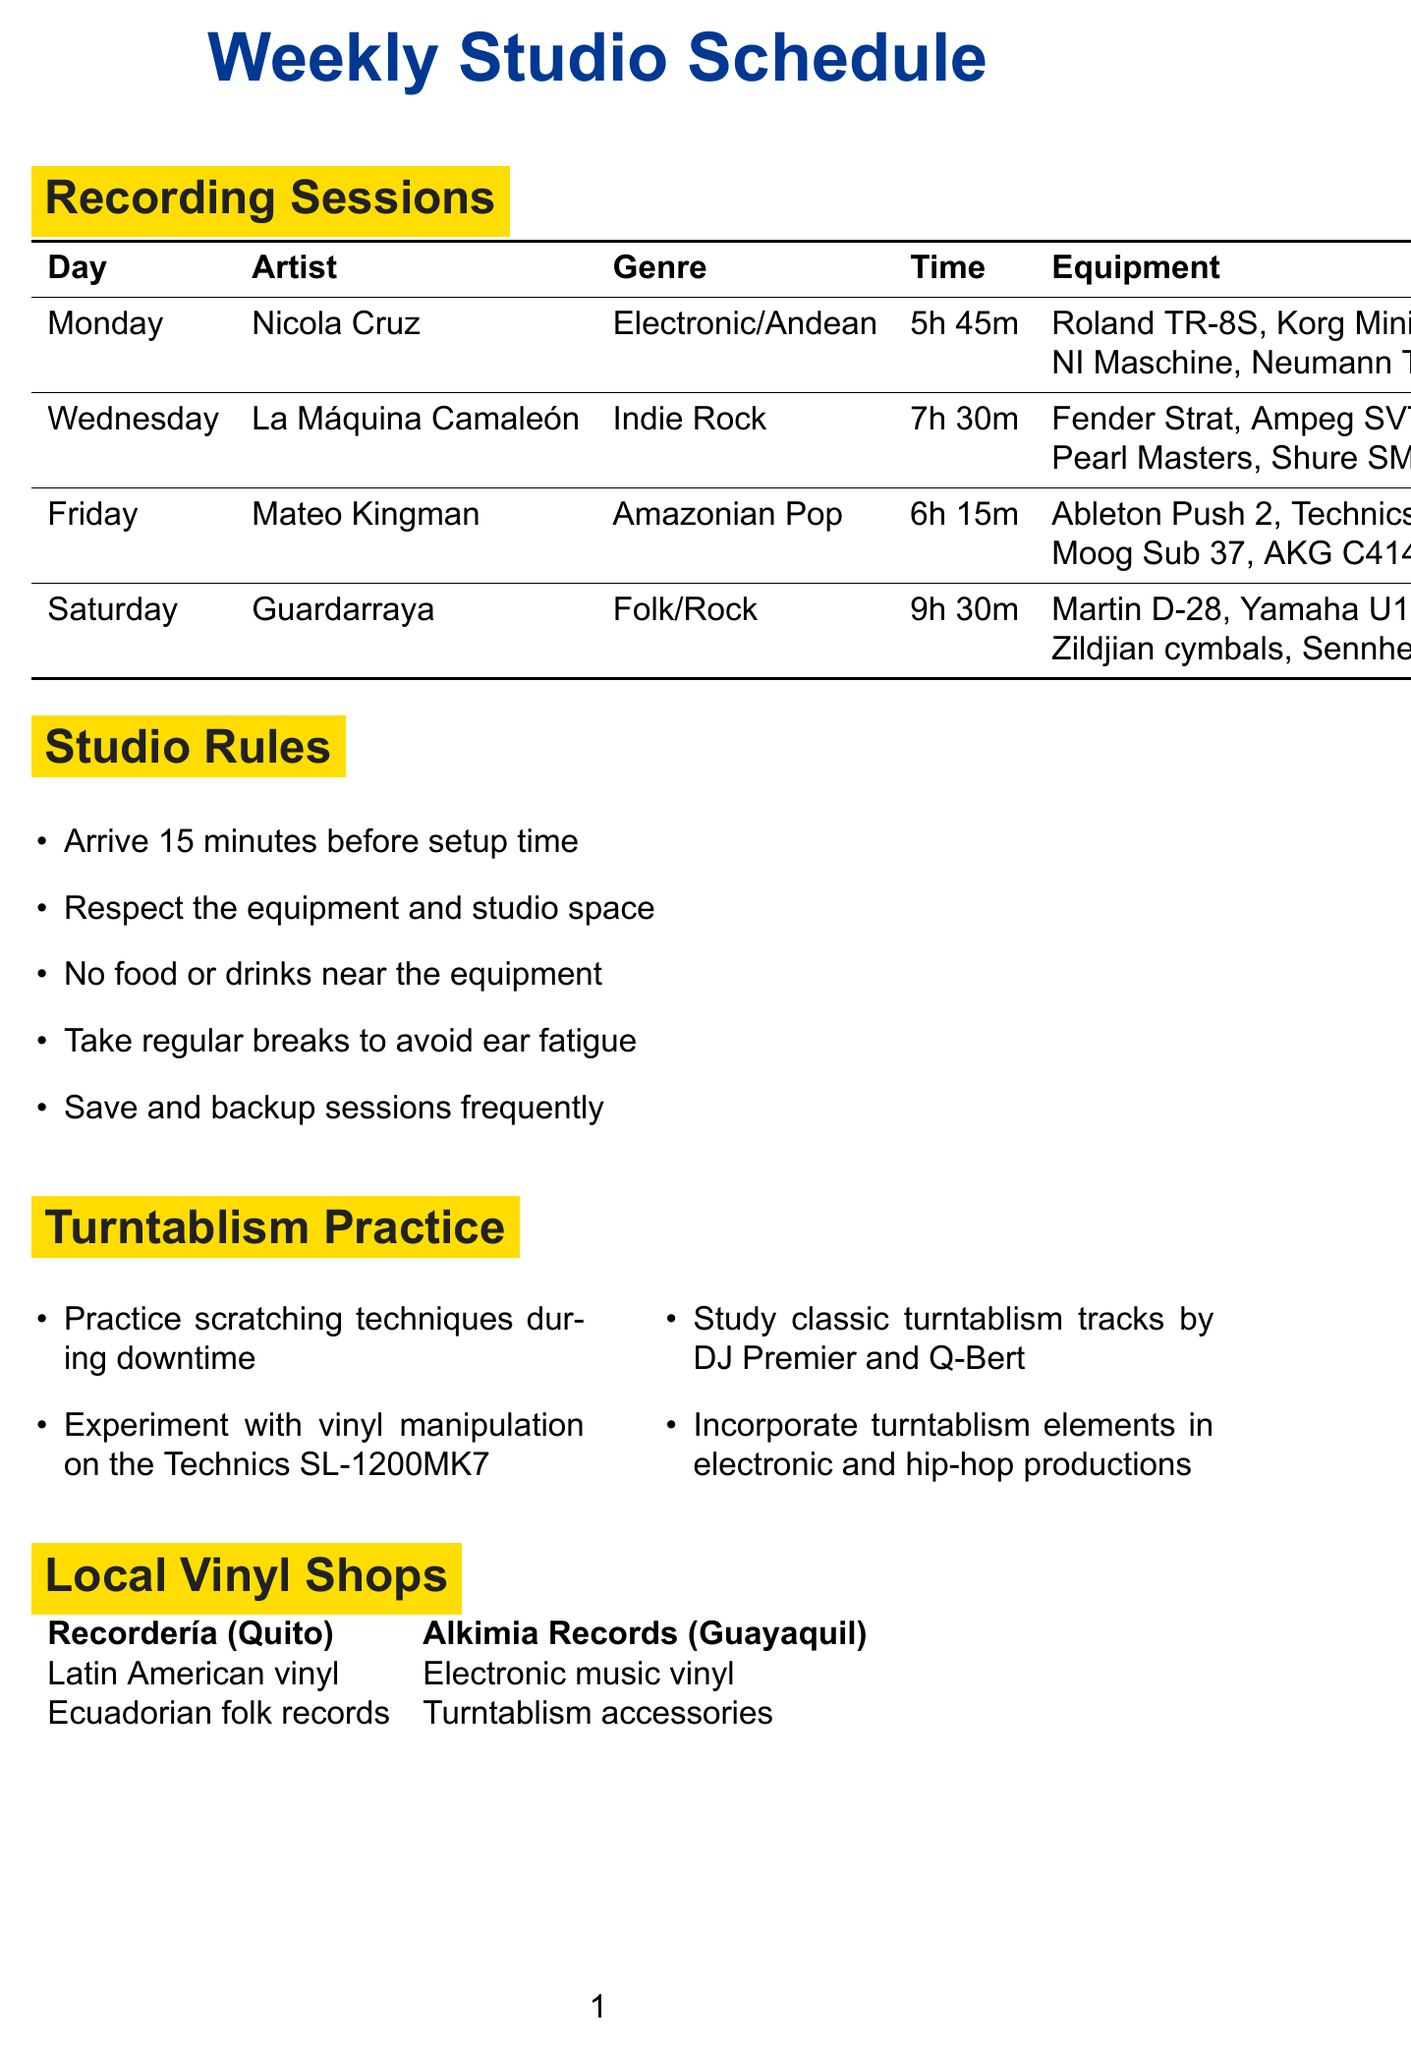what is the name of the artist recording on Wednesday? The document specifies that La Máquina Camaleón is the artist scheduled for Wednesday.
Answer: La Máquina Camaleón how long is the recording time for Mateo Kingman? The recording time listed for Mateo Kingman is 4.5 hours.
Answer: 4.5 hours what genre does Nicola Cruz represent? The genre associated with Nicola Cruz is Electronic/Andean.
Answer: Electronic/Andean which equipment is used for turning vinyl during the sessions? The document mentions that the Technics SL-1200MK7 turntable is used for vinyl manipulation.
Answer: Technics SL-1200MK7 what is the total setup time for Guardarraya's session? The setup time specified for Guardarraya is 2 hours.
Answer: 2 hours how much time is allocated for breakdown after recording with La Máquina Camaleón? The breakdown time after recording with La Máquina Camaleón is 1 hour.
Answer: 1 hour what studio rule advises about food and drinks? The rule states that no food or drinks are allowed near the equipment.
Answer: No food or drinks near the equipment how many pieces of equipment were listed for Friday's session? The equipment list for Mateo Kingman on Friday includes four items.
Answer: four which local vinyl shop specializes in turntablism accessories? Alkimia Records is mentioned as specializing in turntablism accessories.
Answer: Alkimia Records 